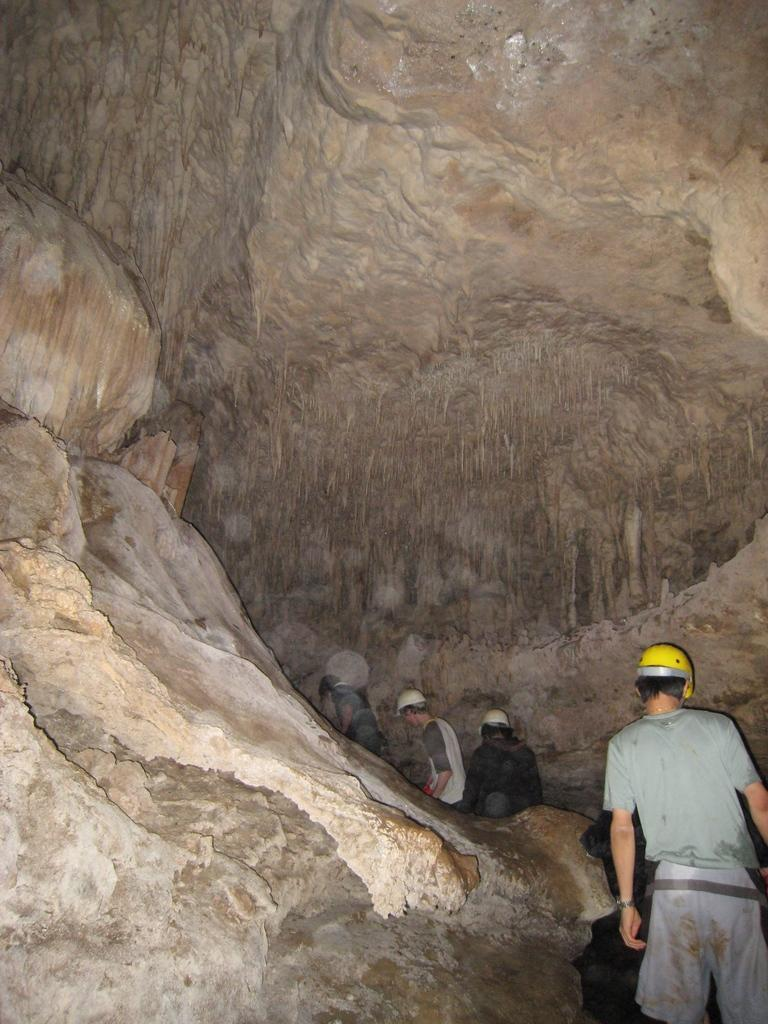How many people are present in the image? There are four persons in the image. Can you describe any objects or features in the image besides the people? Yes, there is a rock in the image. What degree of difficulty is associated with the idea presented by the rock in the image? There is no degree of difficulty or idea presented by the rock in the image, as it is simply a natural object. 